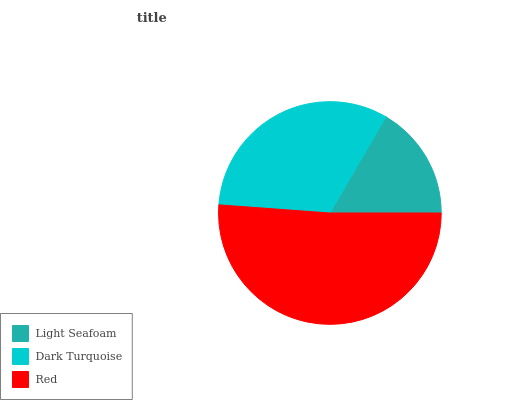Is Light Seafoam the minimum?
Answer yes or no. Yes. Is Red the maximum?
Answer yes or no. Yes. Is Dark Turquoise the minimum?
Answer yes or no. No. Is Dark Turquoise the maximum?
Answer yes or no. No. Is Dark Turquoise greater than Light Seafoam?
Answer yes or no. Yes. Is Light Seafoam less than Dark Turquoise?
Answer yes or no. Yes. Is Light Seafoam greater than Dark Turquoise?
Answer yes or no. No. Is Dark Turquoise less than Light Seafoam?
Answer yes or no. No. Is Dark Turquoise the high median?
Answer yes or no. Yes. Is Dark Turquoise the low median?
Answer yes or no. Yes. Is Red the high median?
Answer yes or no. No. Is Light Seafoam the low median?
Answer yes or no. No. 